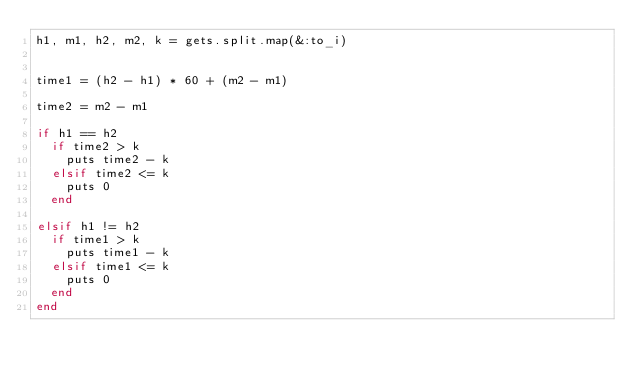<code> <loc_0><loc_0><loc_500><loc_500><_Ruby_>h1, m1, h2, m2, k = gets.split.map(&:to_i)


time1 = (h2 - h1) * 60 + (m2 - m1)

time2 = m2 - m1

if h1 == h2
  if time2 > k
    puts time2 - k
  elsif time2 <= k
    puts 0
  end

elsif h1 != h2
  if time1 > k
    puts time1 - k
  elsif time1 <= k
    puts 0
  end
end</code> 